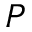Convert formula to latex. <formula><loc_0><loc_0><loc_500><loc_500>P</formula> 